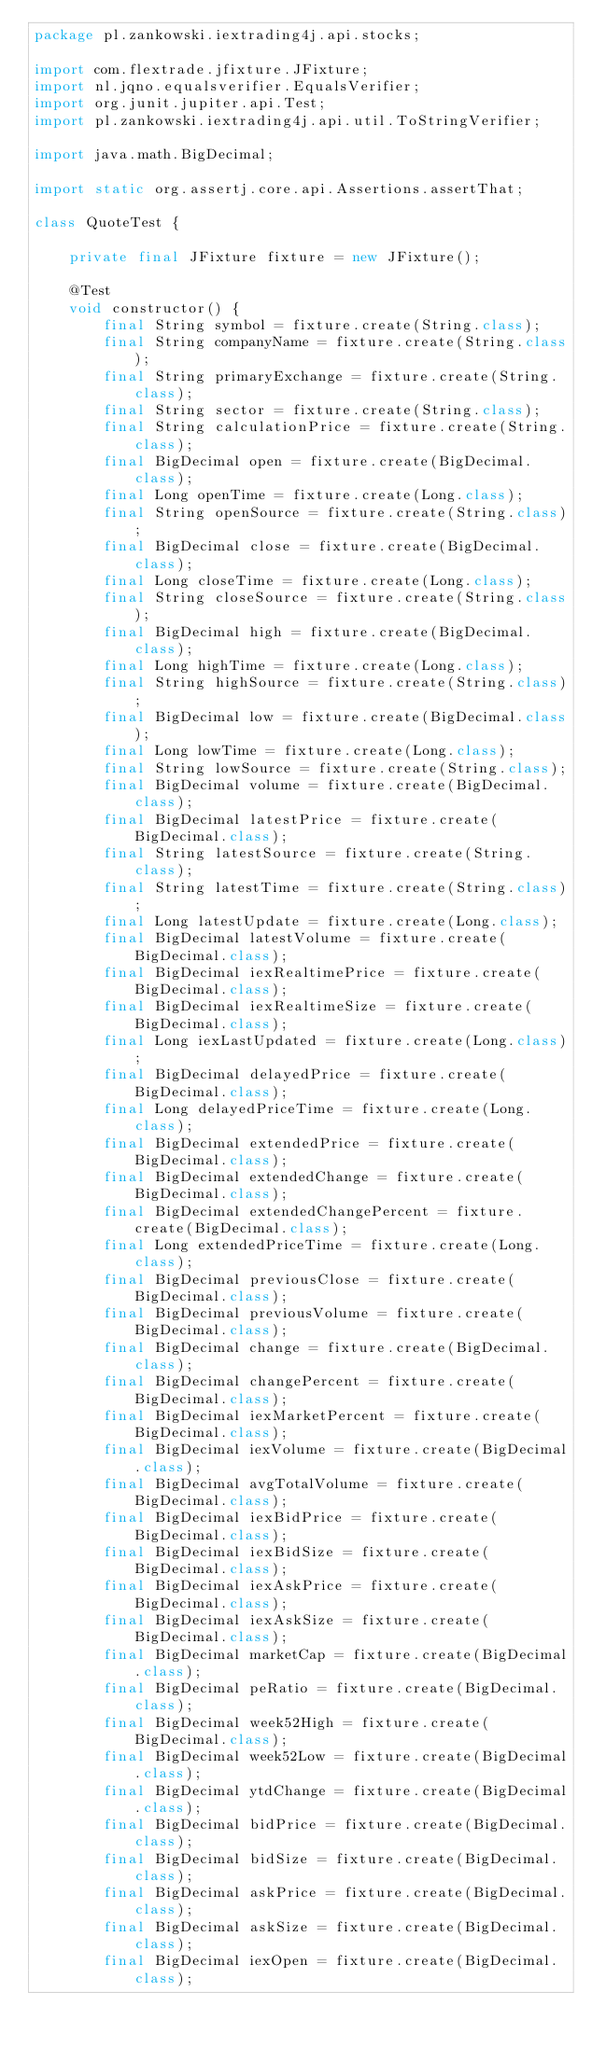Convert code to text. <code><loc_0><loc_0><loc_500><loc_500><_Java_>package pl.zankowski.iextrading4j.api.stocks;

import com.flextrade.jfixture.JFixture;
import nl.jqno.equalsverifier.EqualsVerifier;
import org.junit.jupiter.api.Test;
import pl.zankowski.iextrading4j.api.util.ToStringVerifier;

import java.math.BigDecimal;

import static org.assertj.core.api.Assertions.assertThat;

class QuoteTest {

    private final JFixture fixture = new JFixture();

    @Test
    void constructor() {
        final String symbol = fixture.create(String.class);
        final String companyName = fixture.create(String.class);
        final String primaryExchange = fixture.create(String.class);
        final String sector = fixture.create(String.class);
        final String calculationPrice = fixture.create(String.class);
        final BigDecimal open = fixture.create(BigDecimal.class);
        final Long openTime = fixture.create(Long.class);
        final String openSource = fixture.create(String.class);
        final BigDecimal close = fixture.create(BigDecimal.class);
        final Long closeTime = fixture.create(Long.class);
        final String closeSource = fixture.create(String.class);
        final BigDecimal high = fixture.create(BigDecimal.class);
        final Long highTime = fixture.create(Long.class);
        final String highSource = fixture.create(String.class);
        final BigDecimal low = fixture.create(BigDecimal.class);
        final Long lowTime = fixture.create(Long.class);
        final String lowSource = fixture.create(String.class);
        final BigDecimal volume = fixture.create(BigDecimal.class);
        final BigDecimal latestPrice = fixture.create(BigDecimal.class);
        final String latestSource = fixture.create(String.class);
        final String latestTime = fixture.create(String.class);
        final Long latestUpdate = fixture.create(Long.class);
        final BigDecimal latestVolume = fixture.create(BigDecimal.class);
        final BigDecimal iexRealtimePrice = fixture.create(BigDecimal.class);
        final BigDecimal iexRealtimeSize = fixture.create(BigDecimal.class);
        final Long iexLastUpdated = fixture.create(Long.class);
        final BigDecimal delayedPrice = fixture.create(BigDecimal.class);
        final Long delayedPriceTime = fixture.create(Long.class);
        final BigDecimal extendedPrice = fixture.create(BigDecimal.class);
        final BigDecimal extendedChange = fixture.create(BigDecimal.class);
        final BigDecimal extendedChangePercent = fixture.create(BigDecimal.class);
        final Long extendedPriceTime = fixture.create(Long.class);
        final BigDecimal previousClose = fixture.create(BigDecimal.class);
        final BigDecimal previousVolume = fixture.create(BigDecimal.class);
        final BigDecimal change = fixture.create(BigDecimal.class);
        final BigDecimal changePercent = fixture.create(BigDecimal.class);
        final BigDecimal iexMarketPercent = fixture.create(BigDecimal.class);
        final BigDecimal iexVolume = fixture.create(BigDecimal.class);
        final BigDecimal avgTotalVolume = fixture.create(BigDecimal.class);
        final BigDecimal iexBidPrice = fixture.create(BigDecimal.class);
        final BigDecimal iexBidSize = fixture.create(BigDecimal.class);
        final BigDecimal iexAskPrice = fixture.create(BigDecimal.class);
        final BigDecimal iexAskSize = fixture.create(BigDecimal.class);
        final BigDecimal marketCap = fixture.create(BigDecimal.class);
        final BigDecimal peRatio = fixture.create(BigDecimal.class);
        final BigDecimal week52High = fixture.create(BigDecimal.class);
        final BigDecimal week52Low = fixture.create(BigDecimal.class);
        final BigDecimal ytdChange = fixture.create(BigDecimal.class);
        final BigDecimal bidPrice = fixture.create(BigDecimal.class);
        final BigDecimal bidSize = fixture.create(BigDecimal.class);
        final BigDecimal askPrice = fixture.create(BigDecimal.class);
        final BigDecimal askSize = fixture.create(BigDecimal.class);
        final BigDecimal iexOpen = fixture.create(BigDecimal.class);</code> 